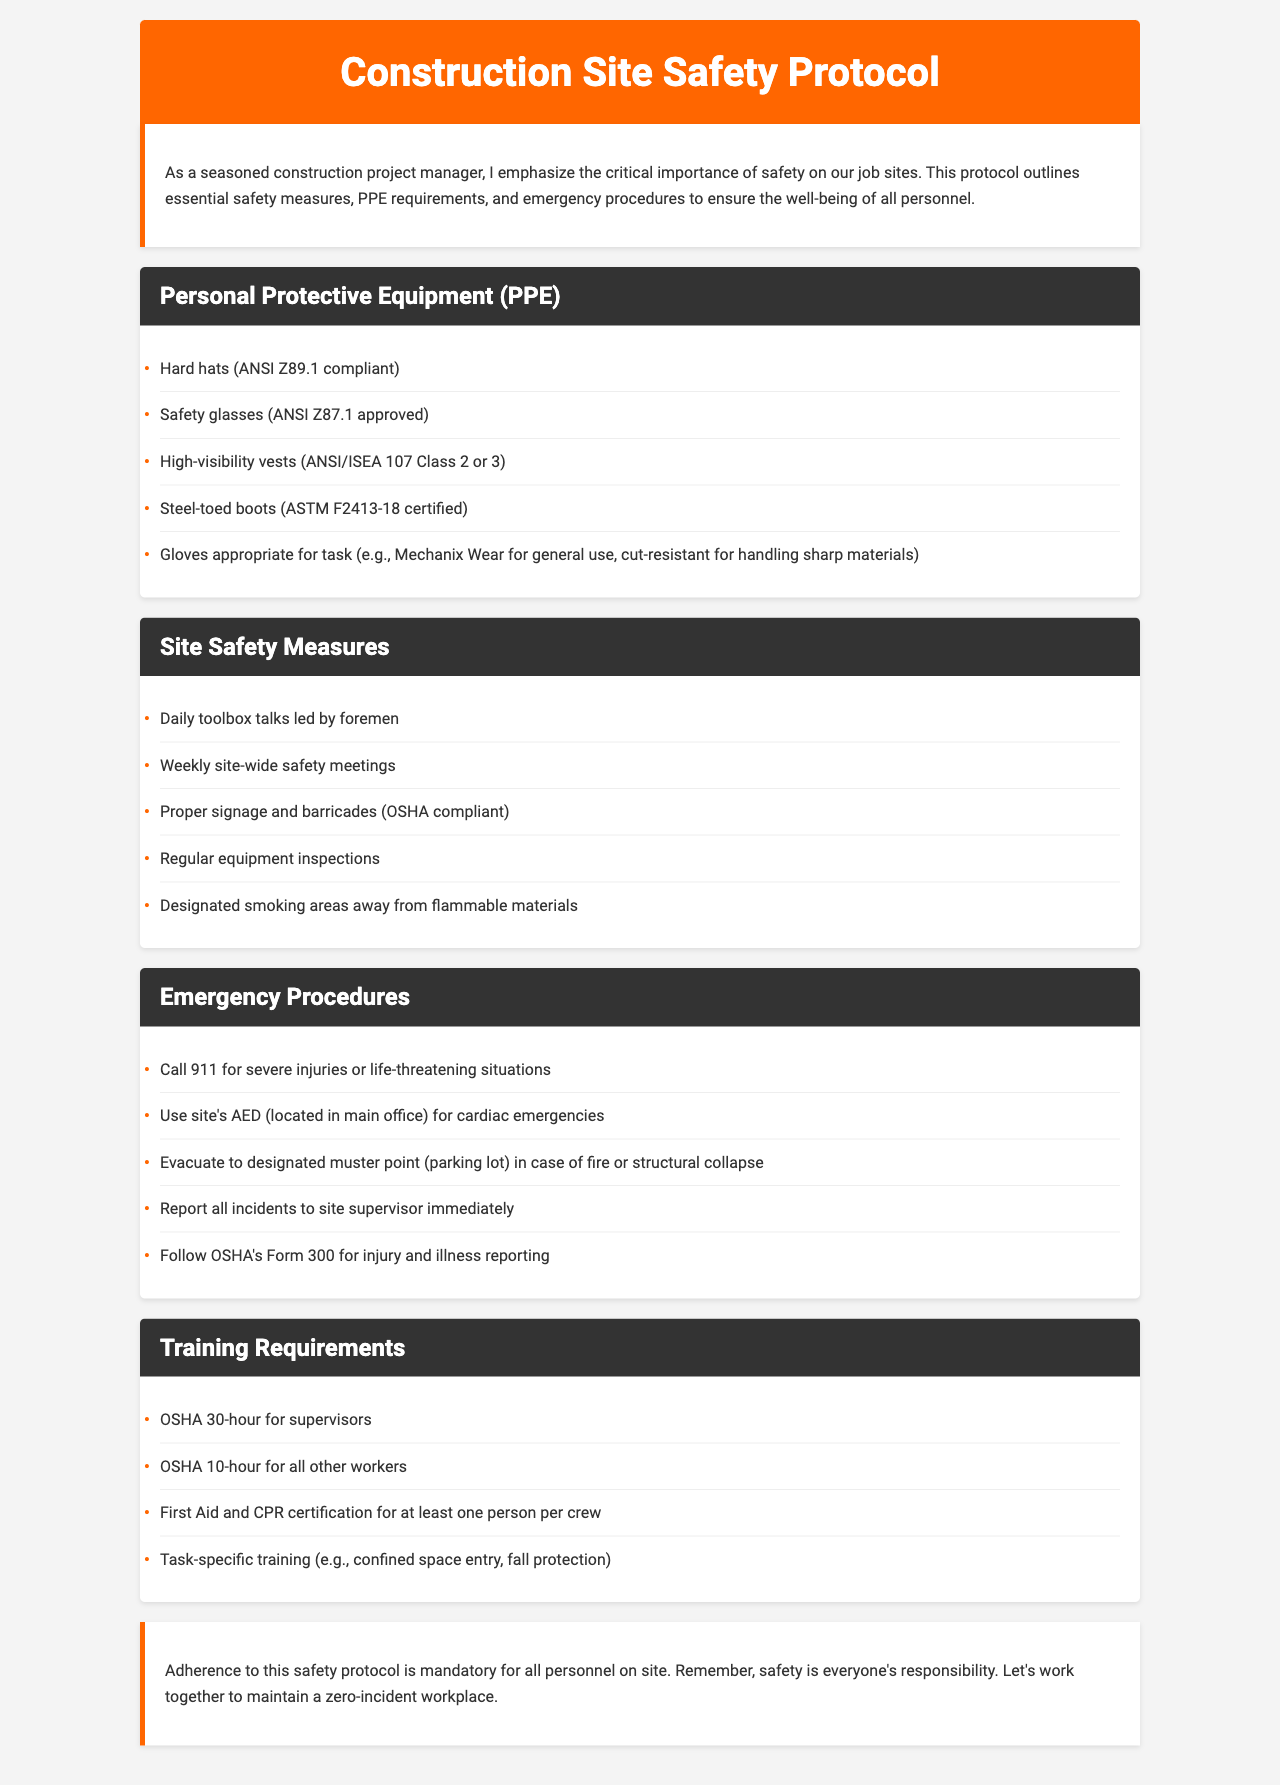what are the PPE requirements listed? PPE requirements include Hard hats, Safety glasses, High-visibility vests, Steel-toed boots, and Gloves appropriate for task.
Answer: Hard hats, Safety glasses, High-visibility vests, Steel-toed boots, Gloves what should be done in case of a fire? In case of a fire, personnel must evacuate to the designated muster point, which is the parking lot.
Answer: evacuate to designated muster point how often are safety meetings held on site? Safety meetings are held weekly as stated in the site safety measures.
Answer: weekly what is required for a crew member's training? At least one person per crew must have First Aid and CPR certification as per the training requirements.
Answer: First Aid and CPR certification what should a worker do if they witness an incident? A worker should report all incidents to the site supervisor immediately according to emergency procedures.
Answer: report to site supervisor what type of hard hats are required? The hard hats must be ANSI Z89.1 compliant as specified under PPE requirements.
Answer: ANSI Z89.1 compliant how long is OSHA training for supervisors? OSHA training for supervisors is a 30-hour course.
Answer: 30-hour where is the AED located on site? The AED is located in the main office for use in cardiac emergencies.
Answer: main office 